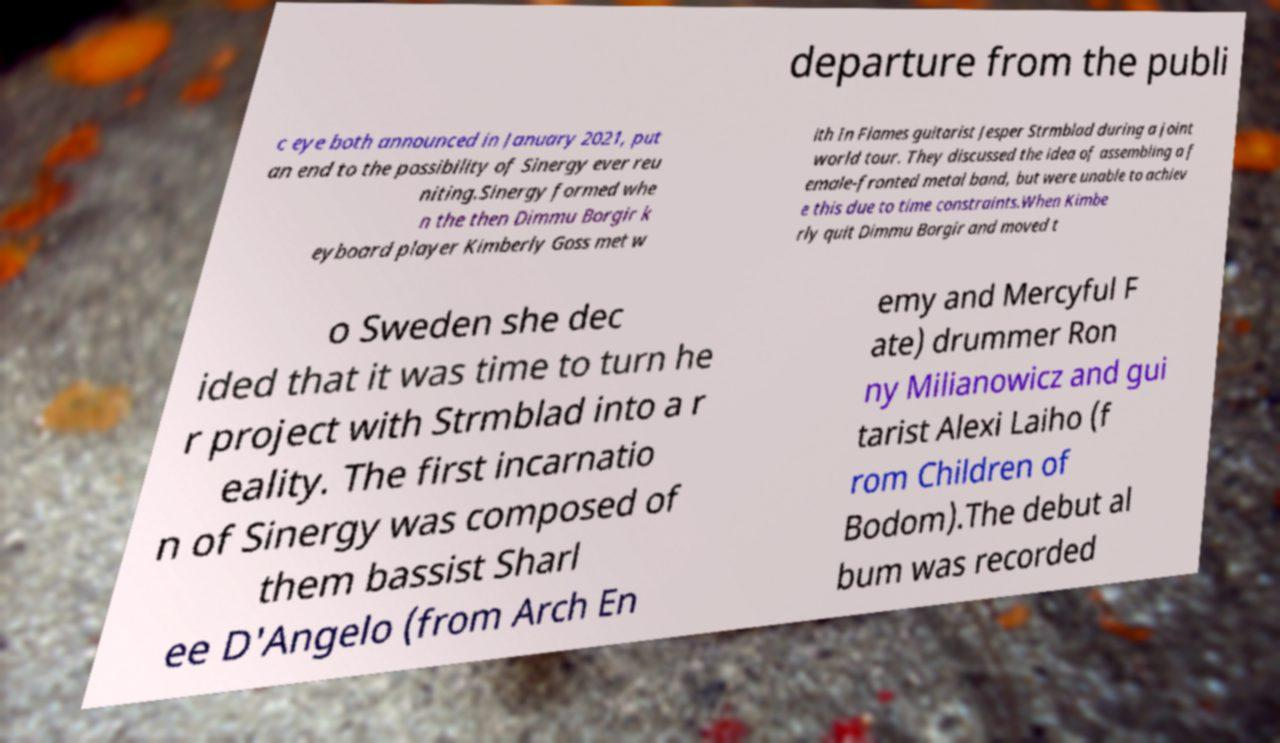Please identify and transcribe the text found in this image. departure from the publi c eye both announced in January 2021, put an end to the possibility of Sinergy ever reu niting.Sinergy formed whe n the then Dimmu Borgir k eyboard player Kimberly Goss met w ith In Flames guitarist Jesper Strmblad during a joint world tour. They discussed the idea of assembling a f emale-fronted metal band, but were unable to achiev e this due to time constraints.When Kimbe rly quit Dimmu Borgir and moved t o Sweden she dec ided that it was time to turn he r project with Strmblad into a r eality. The first incarnatio n of Sinergy was composed of them bassist Sharl ee D'Angelo (from Arch En emy and Mercyful F ate) drummer Ron ny Milianowicz and gui tarist Alexi Laiho (f rom Children of Bodom).The debut al bum was recorded 